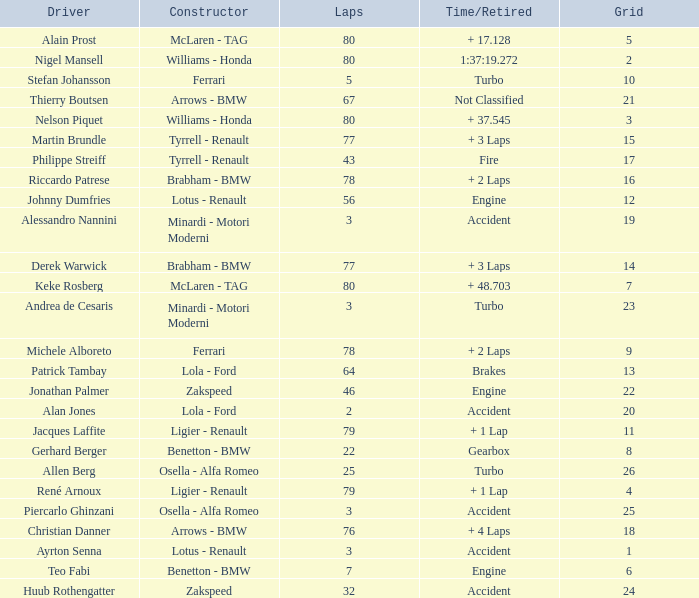What is the time/retired for thierry boutsen? Not Classified. Could you parse the entire table as a dict? {'header': ['Driver', 'Constructor', 'Laps', 'Time/Retired', 'Grid'], 'rows': [['Alain Prost', 'McLaren - TAG', '80', '+ 17.128', '5'], ['Nigel Mansell', 'Williams - Honda', '80', '1:37:19.272', '2'], ['Stefan Johansson', 'Ferrari', '5', 'Turbo', '10'], ['Thierry Boutsen', 'Arrows - BMW', '67', 'Not Classified', '21'], ['Nelson Piquet', 'Williams - Honda', '80', '+ 37.545', '3'], ['Martin Brundle', 'Tyrrell - Renault', '77', '+ 3 Laps', '15'], ['Philippe Streiff', 'Tyrrell - Renault', '43', 'Fire', '17'], ['Riccardo Patrese', 'Brabham - BMW', '78', '+ 2 Laps', '16'], ['Johnny Dumfries', 'Lotus - Renault', '56', 'Engine', '12'], ['Alessandro Nannini', 'Minardi - Motori Moderni', '3', 'Accident', '19'], ['Derek Warwick', 'Brabham - BMW', '77', '+ 3 Laps', '14'], ['Keke Rosberg', 'McLaren - TAG', '80', '+ 48.703', '7'], ['Andrea de Cesaris', 'Minardi - Motori Moderni', '3', 'Turbo', '23'], ['Michele Alboreto', 'Ferrari', '78', '+ 2 Laps', '9'], ['Patrick Tambay', 'Lola - Ford', '64', 'Brakes', '13'], ['Jonathan Palmer', 'Zakspeed', '46', 'Engine', '22'], ['Alan Jones', 'Lola - Ford', '2', 'Accident', '20'], ['Jacques Laffite', 'Ligier - Renault', '79', '+ 1 Lap', '11'], ['Gerhard Berger', 'Benetton - BMW', '22', 'Gearbox', '8'], ['Allen Berg', 'Osella - Alfa Romeo', '25', 'Turbo', '26'], ['René Arnoux', 'Ligier - Renault', '79', '+ 1 Lap', '4'], ['Piercarlo Ghinzani', 'Osella - Alfa Romeo', '3', 'Accident', '25'], ['Christian Danner', 'Arrows - BMW', '76', '+ 4 Laps', '18'], ['Ayrton Senna', 'Lotus - Renault', '3', 'Accident', '1'], ['Teo Fabi', 'Benetton - BMW', '7', 'Engine', '6'], ['Huub Rothengatter', 'Zakspeed', '32', 'Accident', '24']]} 